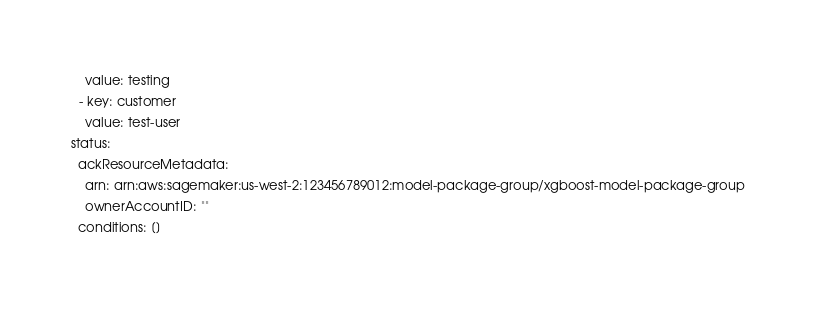<code> <loc_0><loc_0><loc_500><loc_500><_YAML_>    value: testing
  - key: customer
    value: test-user
status:
  ackResourceMetadata:
    arn: arn:aws:sagemaker:us-west-2:123456789012:model-package-group/xgboost-model-package-group
    ownerAccountID: ""
  conditions: []
</code> 